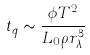<formula> <loc_0><loc_0><loc_500><loc_500>t _ { q } \sim \frac { \phi T ^ { 2 } } { L _ { 0 } \rho r _ { \lambda } ^ { 3 } }</formula> 